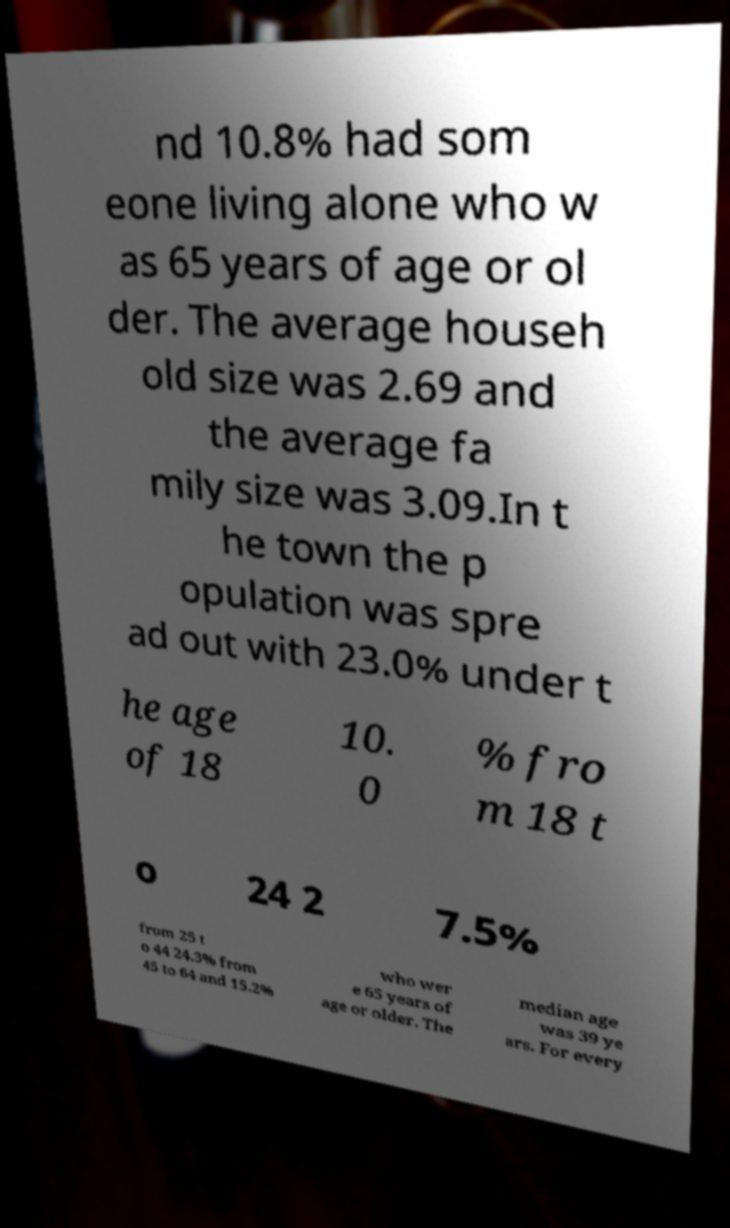Can you accurately transcribe the text from the provided image for me? nd 10.8% had som eone living alone who w as 65 years of age or ol der. The average househ old size was 2.69 and the average fa mily size was 3.09.In t he town the p opulation was spre ad out with 23.0% under t he age of 18 10. 0 % fro m 18 t o 24 2 7.5% from 25 t o 44 24.3% from 45 to 64 and 15.2% who wer e 65 years of age or older. The median age was 39 ye ars. For every 